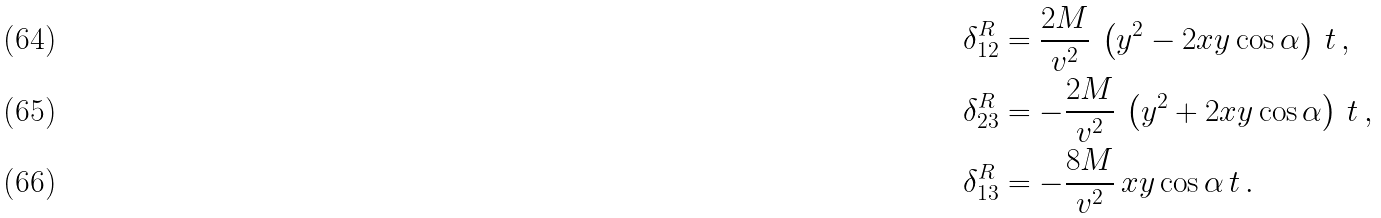<formula> <loc_0><loc_0><loc_500><loc_500>\delta _ { 1 2 } ^ { R } & = \frac { 2 M } { v ^ { 2 } } \, \left ( y ^ { 2 } - 2 x y \cos \alpha \right ) \, t \, , \\ \delta _ { 2 3 } ^ { R } & = - \frac { 2 M } { v ^ { 2 } } \, \left ( y ^ { 2 } + 2 x y \cos \alpha \right ) \, t \, , \\ \delta _ { 1 3 } ^ { R } & = - \frac { 8 M } { v ^ { 2 } } \, x y \cos \alpha \, t \, .</formula> 